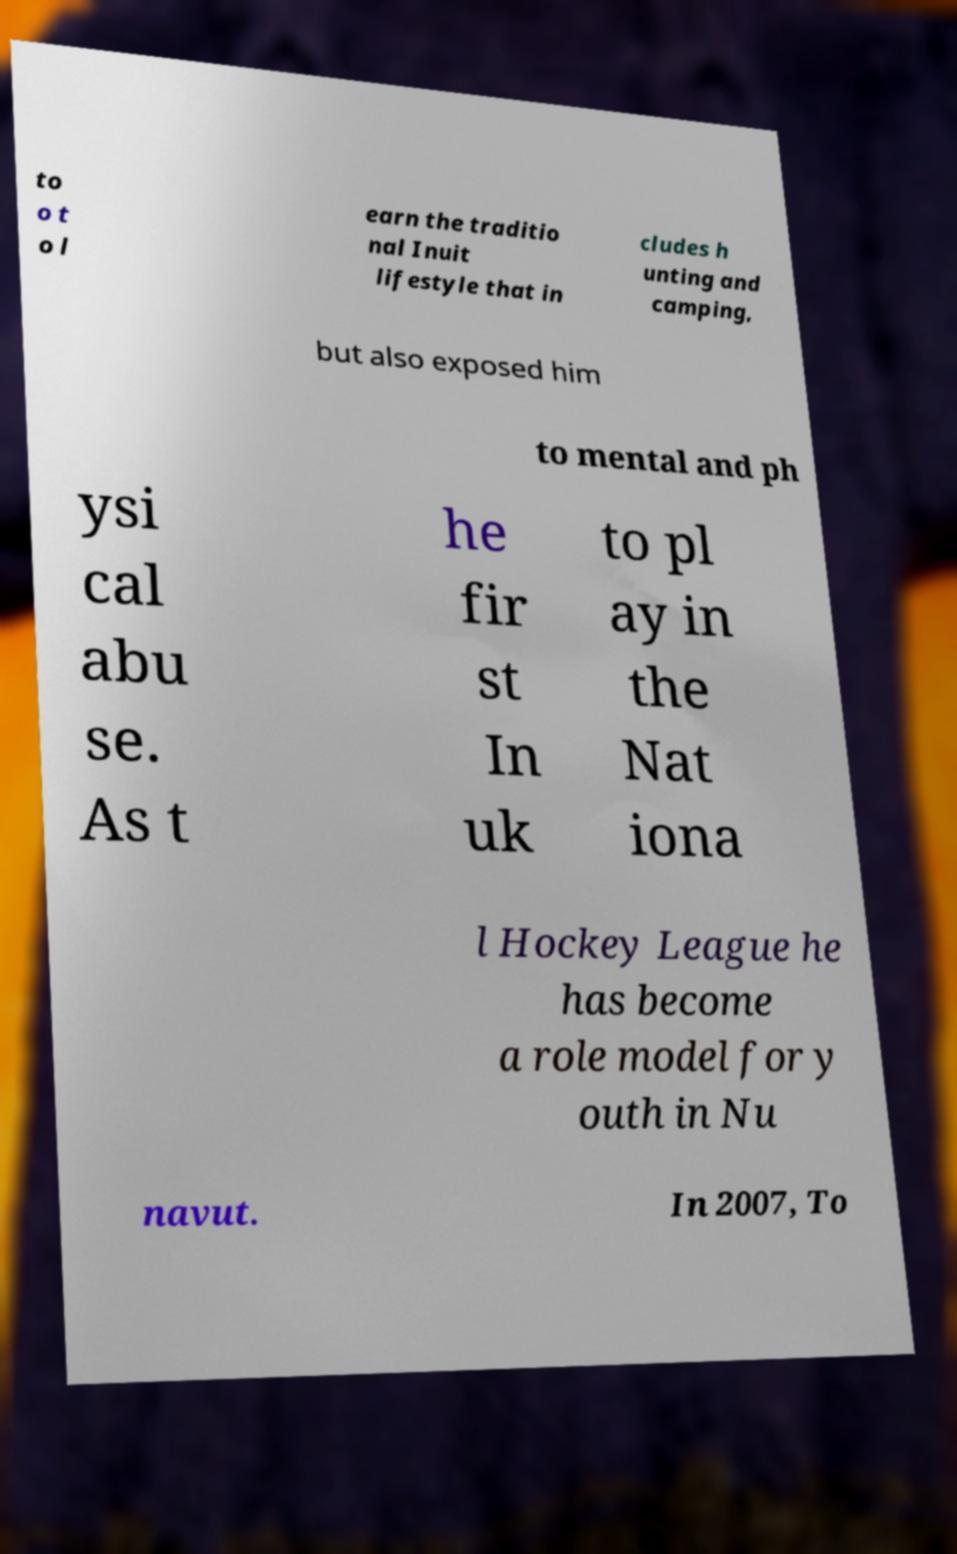I need the written content from this picture converted into text. Can you do that? to o t o l earn the traditio nal Inuit lifestyle that in cludes h unting and camping, but also exposed him to mental and ph ysi cal abu se. As t he fir st In uk to pl ay in the Nat iona l Hockey League he has become a role model for y outh in Nu navut. In 2007, To 